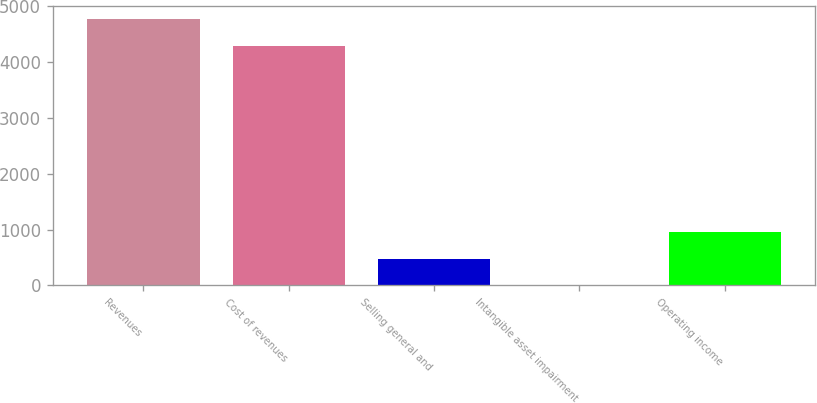<chart> <loc_0><loc_0><loc_500><loc_500><bar_chart><fcel>Revenues<fcel>Cost of revenues<fcel>Selling general and<fcel>Intangible asset impairment<fcel>Operating income<nl><fcel>4770.4<fcel>4295<fcel>481.4<fcel>6<fcel>956.8<nl></chart> 